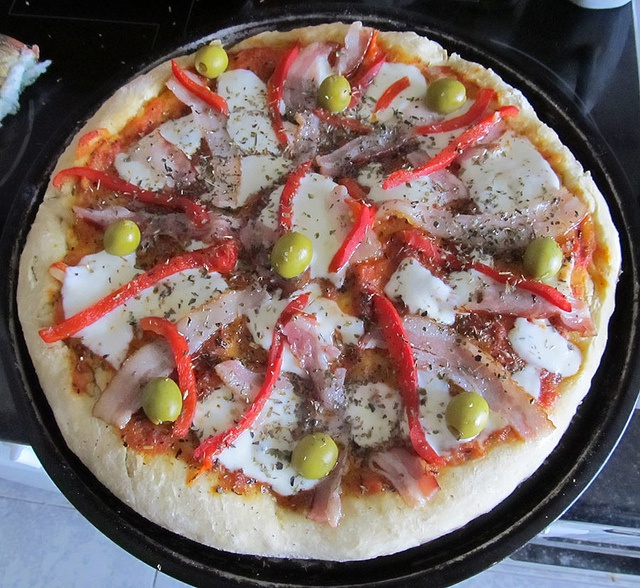Describe the objects in this image and their specific colors. I can see a pizza in black, darkgray, lightgray, brown, and maroon tones in this image. 